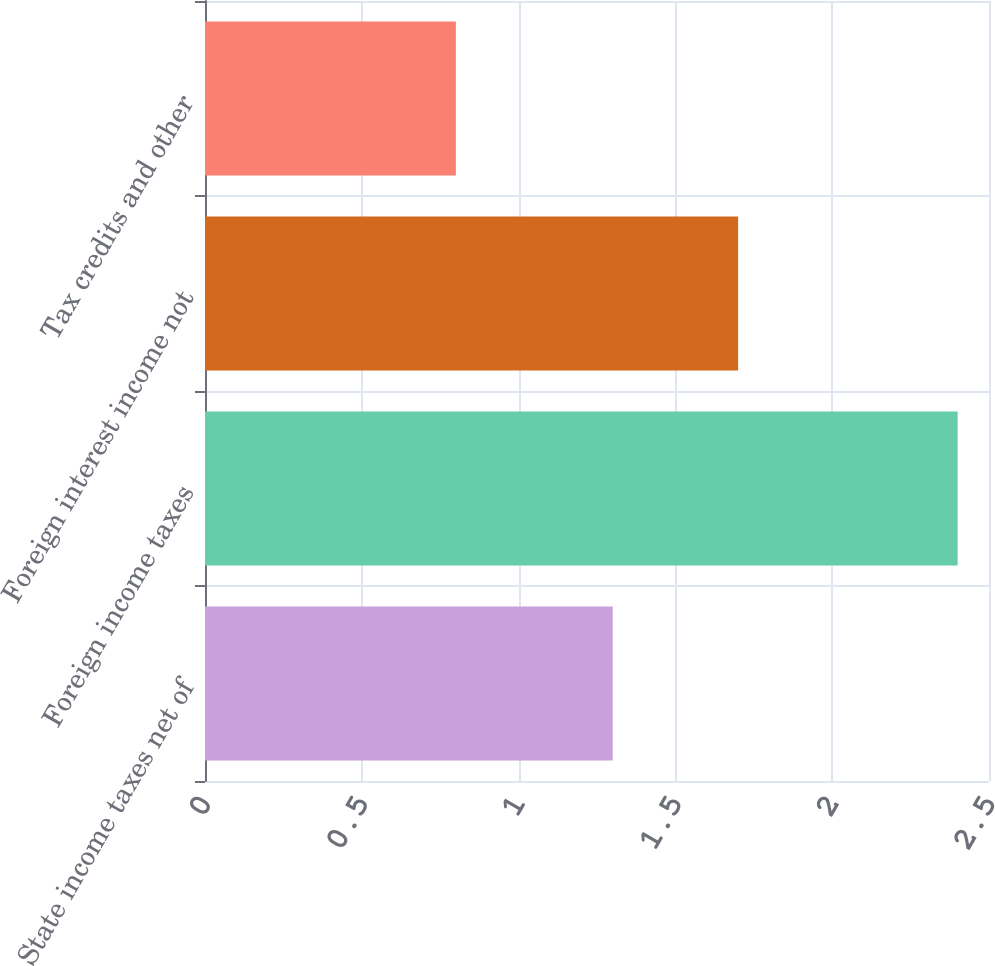Convert chart. <chart><loc_0><loc_0><loc_500><loc_500><bar_chart><fcel>State income taxes net of<fcel>Foreign income taxes<fcel>Foreign interest income not<fcel>Tax credits and other<nl><fcel>1.3<fcel>2.4<fcel>1.7<fcel>0.8<nl></chart> 